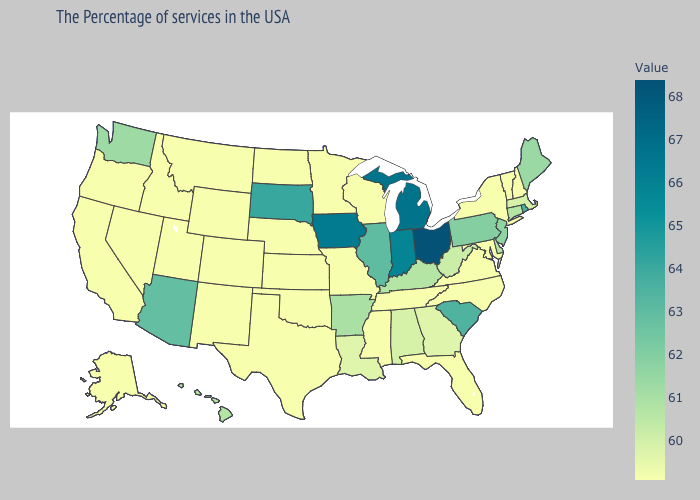Among the states that border Tennessee , does Missouri have the highest value?
Answer briefly. No. Does South Dakota have the lowest value in the MidWest?
Be succinct. No. Does the map have missing data?
Write a very short answer. No. Among the states that border Louisiana , which have the highest value?
Write a very short answer. Arkansas. 